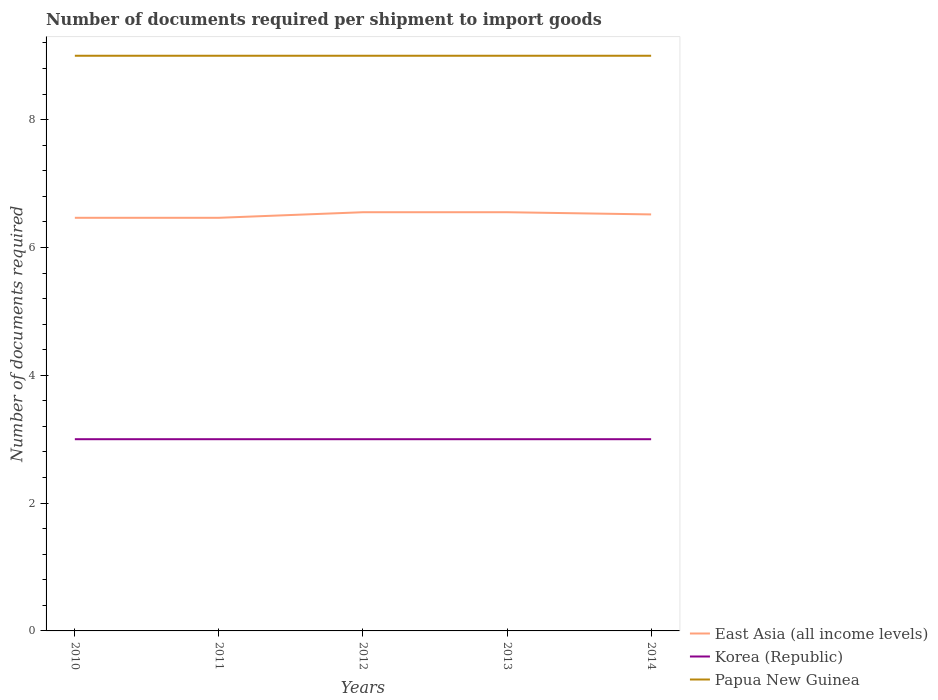Does the line corresponding to Papua New Guinea intersect with the line corresponding to East Asia (all income levels)?
Provide a short and direct response. No. Across all years, what is the maximum number of documents required per shipment to import goods in Papua New Guinea?
Your response must be concise. 9. In which year was the number of documents required per shipment to import goods in Papua New Guinea maximum?
Provide a succinct answer. 2010. What is the difference between the highest and the lowest number of documents required per shipment to import goods in East Asia (all income levels)?
Provide a short and direct response. 3. Is the number of documents required per shipment to import goods in Papua New Guinea strictly greater than the number of documents required per shipment to import goods in Korea (Republic) over the years?
Your answer should be compact. No. How many years are there in the graph?
Give a very brief answer. 5. Are the values on the major ticks of Y-axis written in scientific E-notation?
Give a very brief answer. No. Where does the legend appear in the graph?
Give a very brief answer. Bottom right. How many legend labels are there?
Keep it short and to the point. 3. How are the legend labels stacked?
Keep it short and to the point. Vertical. What is the title of the graph?
Offer a terse response. Number of documents required per shipment to import goods. Does "India" appear as one of the legend labels in the graph?
Provide a short and direct response. No. What is the label or title of the Y-axis?
Your response must be concise. Number of documents required. What is the Number of documents required of East Asia (all income levels) in 2010?
Offer a very short reply. 6.46. What is the Number of documents required of Korea (Republic) in 2010?
Offer a terse response. 3. What is the Number of documents required of East Asia (all income levels) in 2011?
Ensure brevity in your answer.  6.46. What is the Number of documents required in East Asia (all income levels) in 2012?
Give a very brief answer. 6.55. What is the Number of documents required in East Asia (all income levels) in 2013?
Your response must be concise. 6.55. What is the Number of documents required of Korea (Republic) in 2013?
Offer a terse response. 3. What is the Number of documents required in East Asia (all income levels) in 2014?
Provide a short and direct response. 6.52. What is the Number of documents required of Korea (Republic) in 2014?
Your response must be concise. 3. Across all years, what is the maximum Number of documents required of East Asia (all income levels)?
Make the answer very short. 6.55. Across all years, what is the maximum Number of documents required of Papua New Guinea?
Ensure brevity in your answer.  9. Across all years, what is the minimum Number of documents required of East Asia (all income levels)?
Provide a succinct answer. 6.46. What is the total Number of documents required of East Asia (all income levels) in the graph?
Provide a short and direct response. 32.55. What is the total Number of documents required of Korea (Republic) in the graph?
Offer a terse response. 15. What is the difference between the Number of documents required in East Asia (all income levels) in 2010 and that in 2011?
Offer a terse response. 0. What is the difference between the Number of documents required in Korea (Republic) in 2010 and that in 2011?
Your answer should be compact. 0. What is the difference between the Number of documents required in Papua New Guinea in 2010 and that in 2011?
Your answer should be very brief. 0. What is the difference between the Number of documents required in East Asia (all income levels) in 2010 and that in 2012?
Your response must be concise. -0.09. What is the difference between the Number of documents required in Papua New Guinea in 2010 and that in 2012?
Make the answer very short. 0. What is the difference between the Number of documents required in East Asia (all income levels) in 2010 and that in 2013?
Offer a terse response. -0.09. What is the difference between the Number of documents required in Papua New Guinea in 2010 and that in 2013?
Give a very brief answer. 0. What is the difference between the Number of documents required of East Asia (all income levels) in 2010 and that in 2014?
Offer a terse response. -0.05. What is the difference between the Number of documents required of Korea (Republic) in 2010 and that in 2014?
Provide a succinct answer. 0. What is the difference between the Number of documents required of East Asia (all income levels) in 2011 and that in 2012?
Your response must be concise. -0.09. What is the difference between the Number of documents required in East Asia (all income levels) in 2011 and that in 2013?
Keep it short and to the point. -0.09. What is the difference between the Number of documents required of Papua New Guinea in 2011 and that in 2013?
Give a very brief answer. 0. What is the difference between the Number of documents required of East Asia (all income levels) in 2011 and that in 2014?
Provide a short and direct response. -0.05. What is the difference between the Number of documents required of Papua New Guinea in 2011 and that in 2014?
Give a very brief answer. 0. What is the difference between the Number of documents required of East Asia (all income levels) in 2012 and that in 2013?
Keep it short and to the point. 0. What is the difference between the Number of documents required in East Asia (all income levels) in 2012 and that in 2014?
Provide a succinct answer. 0.03. What is the difference between the Number of documents required of Papua New Guinea in 2012 and that in 2014?
Provide a succinct answer. 0. What is the difference between the Number of documents required of East Asia (all income levels) in 2013 and that in 2014?
Your answer should be compact. 0.03. What is the difference between the Number of documents required in Korea (Republic) in 2013 and that in 2014?
Offer a terse response. 0. What is the difference between the Number of documents required in East Asia (all income levels) in 2010 and the Number of documents required in Korea (Republic) in 2011?
Your response must be concise. 3.46. What is the difference between the Number of documents required of East Asia (all income levels) in 2010 and the Number of documents required of Papua New Guinea in 2011?
Your answer should be compact. -2.54. What is the difference between the Number of documents required of Korea (Republic) in 2010 and the Number of documents required of Papua New Guinea in 2011?
Your answer should be compact. -6. What is the difference between the Number of documents required of East Asia (all income levels) in 2010 and the Number of documents required of Korea (Republic) in 2012?
Your response must be concise. 3.46. What is the difference between the Number of documents required in East Asia (all income levels) in 2010 and the Number of documents required in Papua New Guinea in 2012?
Your answer should be compact. -2.54. What is the difference between the Number of documents required of East Asia (all income levels) in 2010 and the Number of documents required of Korea (Republic) in 2013?
Give a very brief answer. 3.46. What is the difference between the Number of documents required of East Asia (all income levels) in 2010 and the Number of documents required of Papua New Guinea in 2013?
Keep it short and to the point. -2.54. What is the difference between the Number of documents required in East Asia (all income levels) in 2010 and the Number of documents required in Korea (Republic) in 2014?
Make the answer very short. 3.46. What is the difference between the Number of documents required in East Asia (all income levels) in 2010 and the Number of documents required in Papua New Guinea in 2014?
Provide a short and direct response. -2.54. What is the difference between the Number of documents required of East Asia (all income levels) in 2011 and the Number of documents required of Korea (Republic) in 2012?
Offer a terse response. 3.46. What is the difference between the Number of documents required of East Asia (all income levels) in 2011 and the Number of documents required of Papua New Guinea in 2012?
Your response must be concise. -2.54. What is the difference between the Number of documents required of Korea (Republic) in 2011 and the Number of documents required of Papua New Guinea in 2012?
Provide a short and direct response. -6. What is the difference between the Number of documents required in East Asia (all income levels) in 2011 and the Number of documents required in Korea (Republic) in 2013?
Offer a terse response. 3.46. What is the difference between the Number of documents required in East Asia (all income levels) in 2011 and the Number of documents required in Papua New Guinea in 2013?
Your answer should be very brief. -2.54. What is the difference between the Number of documents required of East Asia (all income levels) in 2011 and the Number of documents required of Korea (Republic) in 2014?
Ensure brevity in your answer.  3.46. What is the difference between the Number of documents required of East Asia (all income levels) in 2011 and the Number of documents required of Papua New Guinea in 2014?
Your response must be concise. -2.54. What is the difference between the Number of documents required of Korea (Republic) in 2011 and the Number of documents required of Papua New Guinea in 2014?
Offer a terse response. -6. What is the difference between the Number of documents required of East Asia (all income levels) in 2012 and the Number of documents required of Korea (Republic) in 2013?
Give a very brief answer. 3.55. What is the difference between the Number of documents required of East Asia (all income levels) in 2012 and the Number of documents required of Papua New Guinea in 2013?
Keep it short and to the point. -2.45. What is the difference between the Number of documents required in Korea (Republic) in 2012 and the Number of documents required in Papua New Guinea in 2013?
Give a very brief answer. -6. What is the difference between the Number of documents required of East Asia (all income levels) in 2012 and the Number of documents required of Korea (Republic) in 2014?
Make the answer very short. 3.55. What is the difference between the Number of documents required of East Asia (all income levels) in 2012 and the Number of documents required of Papua New Guinea in 2014?
Make the answer very short. -2.45. What is the difference between the Number of documents required of East Asia (all income levels) in 2013 and the Number of documents required of Korea (Republic) in 2014?
Offer a very short reply. 3.55. What is the difference between the Number of documents required of East Asia (all income levels) in 2013 and the Number of documents required of Papua New Guinea in 2014?
Give a very brief answer. -2.45. What is the average Number of documents required of East Asia (all income levels) per year?
Ensure brevity in your answer.  6.51. What is the average Number of documents required in Papua New Guinea per year?
Your response must be concise. 9. In the year 2010, what is the difference between the Number of documents required of East Asia (all income levels) and Number of documents required of Korea (Republic)?
Give a very brief answer. 3.46. In the year 2010, what is the difference between the Number of documents required of East Asia (all income levels) and Number of documents required of Papua New Guinea?
Your answer should be very brief. -2.54. In the year 2010, what is the difference between the Number of documents required of Korea (Republic) and Number of documents required of Papua New Guinea?
Give a very brief answer. -6. In the year 2011, what is the difference between the Number of documents required of East Asia (all income levels) and Number of documents required of Korea (Republic)?
Make the answer very short. 3.46. In the year 2011, what is the difference between the Number of documents required of East Asia (all income levels) and Number of documents required of Papua New Guinea?
Provide a succinct answer. -2.54. In the year 2012, what is the difference between the Number of documents required of East Asia (all income levels) and Number of documents required of Korea (Republic)?
Provide a succinct answer. 3.55. In the year 2012, what is the difference between the Number of documents required in East Asia (all income levels) and Number of documents required in Papua New Guinea?
Offer a very short reply. -2.45. In the year 2013, what is the difference between the Number of documents required in East Asia (all income levels) and Number of documents required in Korea (Republic)?
Provide a succinct answer. 3.55. In the year 2013, what is the difference between the Number of documents required in East Asia (all income levels) and Number of documents required in Papua New Guinea?
Offer a very short reply. -2.45. In the year 2014, what is the difference between the Number of documents required of East Asia (all income levels) and Number of documents required of Korea (Republic)?
Offer a terse response. 3.52. In the year 2014, what is the difference between the Number of documents required of East Asia (all income levels) and Number of documents required of Papua New Guinea?
Offer a terse response. -2.48. In the year 2014, what is the difference between the Number of documents required in Korea (Republic) and Number of documents required in Papua New Guinea?
Offer a terse response. -6. What is the ratio of the Number of documents required in East Asia (all income levels) in 2010 to that in 2012?
Ensure brevity in your answer.  0.99. What is the ratio of the Number of documents required in East Asia (all income levels) in 2010 to that in 2013?
Offer a terse response. 0.99. What is the ratio of the Number of documents required in Papua New Guinea in 2010 to that in 2013?
Your answer should be very brief. 1. What is the ratio of the Number of documents required in Papua New Guinea in 2010 to that in 2014?
Offer a very short reply. 1. What is the ratio of the Number of documents required in East Asia (all income levels) in 2011 to that in 2012?
Keep it short and to the point. 0.99. What is the ratio of the Number of documents required of East Asia (all income levels) in 2011 to that in 2013?
Provide a short and direct response. 0.99. What is the ratio of the Number of documents required in Korea (Republic) in 2011 to that in 2013?
Offer a terse response. 1. What is the ratio of the Number of documents required in Papua New Guinea in 2011 to that in 2013?
Provide a short and direct response. 1. What is the ratio of the Number of documents required of East Asia (all income levels) in 2011 to that in 2014?
Ensure brevity in your answer.  0.99. What is the ratio of the Number of documents required of Korea (Republic) in 2011 to that in 2014?
Provide a short and direct response. 1. What is the ratio of the Number of documents required in Papua New Guinea in 2011 to that in 2014?
Make the answer very short. 1. What is the ratio of the Number of documents required in Papua New Guinea in 2012 to that in 2013?
Give a very brief answer. 1. What is the ratio of the Number of documents required of East Asia (all income levels) in 2012 to that in 2014?
Your response must be concise. 1.01. What is the ratio of the Number of documents required of Korea (Republic) in 2012 to that in 2014?
Offer a very short reply. 1. What is the ratio of the Number of documents required in East Asia (all income levels) in 2013 to that in 2014?
Your answer should be compact. 1.01. What is the difference between the highest and the second highest Number of documents required in Korea (Republic)?
Keep it short and to the point. 0. What is the difference between the highest and the lowest Number of documents required in East Asia (all income levels)?
Give a very brief answer. 0.09. 